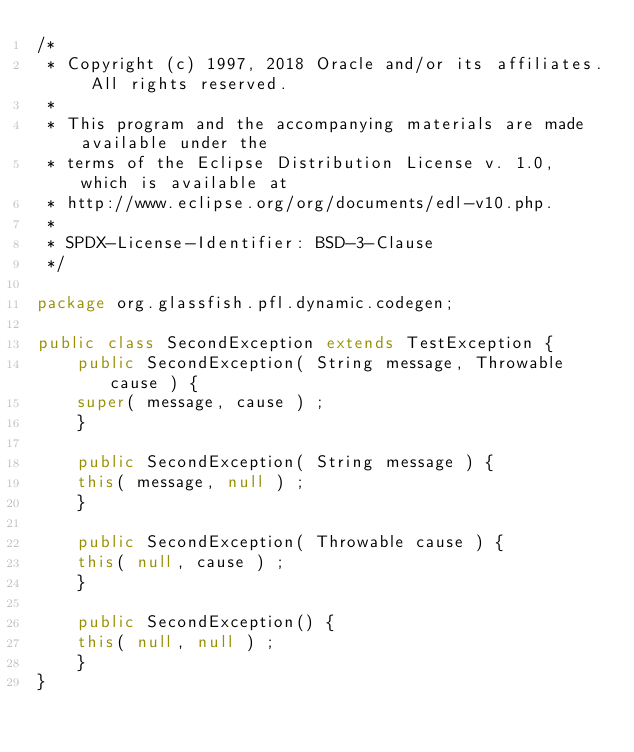<code> <loc_0><loc_0><loc_500><loc_500><_Java_>/*
 * Copyright (c) 1997, 2018 Oracle and/or its affiliates. All rights reserved.
 *
 * This program and the accompanying materials are made available under the
 * terms of the Eclipse Distribution License v. 1.0, which is available at
 * http://www.eclipse.org/org/documents/edl-v10.php.
 *
 * SPDX-License-Identifier: BSD-3-Clause
 */

package org.glassfish.pfl.dynamic.codegen;

public class SecondException extends TestException {
    public SecondException( String message, Throwable cause ) {
	super( message, cause ) ;
    }

    public SecondException( String message ) {
	this( message, null ) ;
    }

    public SecondException( Throwable cause ) {
	this( null, cause ) ;
    }

    public SecondException() {
	this( null, null ) ;
    }
}

</code> 